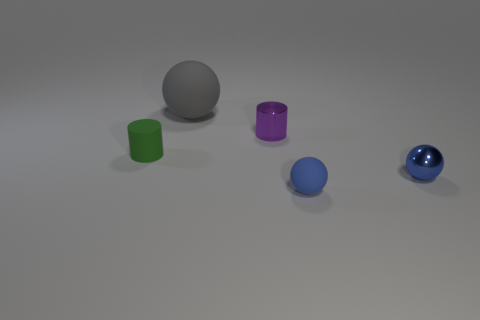What material is the other green cylinder that is the same size as the shiny cylinder?
Offer a terse response. Rubber. Does the rubber thing left of the large gray object have the same shape as the blue metal object?
Offer a terse response. No. Are there more tiny objects that are behind the small green matte cylinder than small blue things behind the big matte object?
Offer a terse response. Yes. How many other small objects are made of the same material as the gray thing?
Provide a succinct answer. 2. Do the green matte cylinder and the purple cylinder have the same size?
Offer a terse response. Yes. What color is the small matte cylinder?
Keep it short and to the point. Green. What number of objects are cyan shiny cylinders or green objects?
Your response must be concise. 1. Are there any other small rubber objects of the same shape as the blue rubber object?
Your response must be concise. No. Do the cylinder that is on the left side of the big rubber object and the shiny ball have the same color?
Provide a succinct answer. No. The small metallic thing that is behind the tiny sphere right of the small rubber sphere is what shape?
Your answer should be compact. Cylinder. 